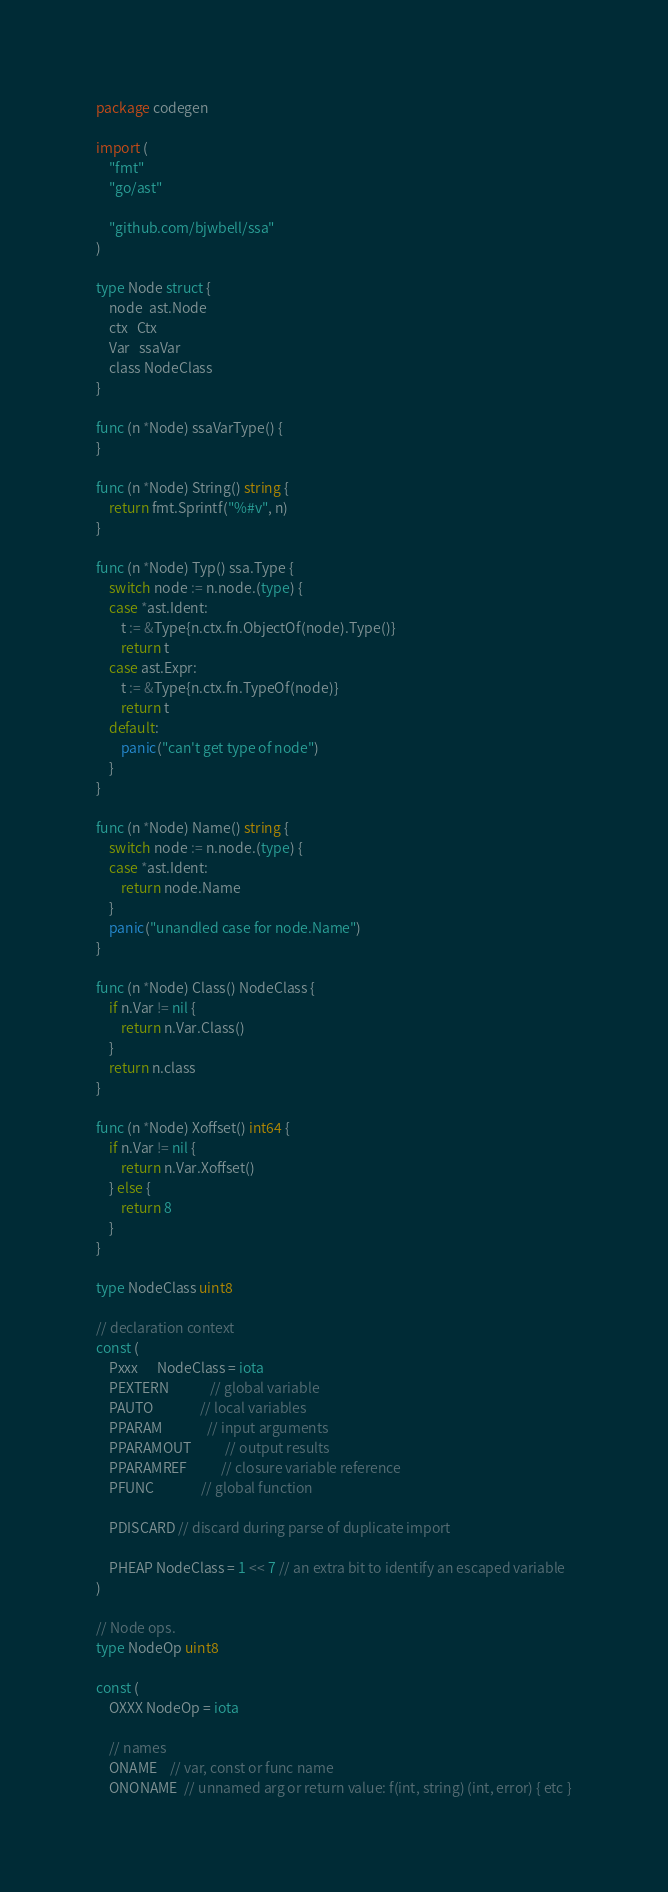Convert code to text. <code><loc_0><loc_0><loc_500><loc_500><_Go_>package codegen

import (
	"fmt"
	"go/ast"

	"github.com/bjwbell/ssa"
)

type Node struct {
	node  ast.Node
	ctx   Ctx
	Var   ssaVar
	class NodeClass
}

func (n *Node) ssaVarType() {
}

func (n *Node) String() string {
	return fmt.Sprintf("%#v", n)
}

func (n *Node) Typ() ssa.Type {
	switch node := n.node.(type) {
	case *ast.Ident:
		t := &Type{n.ctx.fn.ObjectOf(node).Type()}
		return t
	case ast.Expr:
		t := &Type{n.ctx.fn.TypeOf(node)}
		return t
	default:
		panic("can't get type of node")
	}
}

func (n *Node) Name() string {
	switch node := n.node.(type) {
	case *ast.Ident:
		return node.Name
	}
	panic("unandled case for node.Name")
}

func (n *Node) Class() NodeClass {
	if n.Var != nil {
		return n.Var.Class()
	}
	return n.class
}

func (n *Node) Xoffset() int64 {
	if n.Var != nil {
		return n.Var.Xoffset()
	} else {
		return 8
	}
}

type NodeClass uint8

// declaration context
const (
	Pxxx      NodeClass = iota
	PEXTERN             // global variable
	PAUTO               // local variables
	PPARAM              // input arguments
	PPARAMOUT           // output results
	PPARAMREF           // closure variable reference
	PFUNC               // global function

	PDISCARD // discard during parse of duplicate import

	PHEAP NodeClass = 1 << 7 // an extra bit to identify an escaped variable
)

// Node ops.
type NodeOp uint8

const (
	OXXX NodeOp = iota

	// names
	ONAME    // var, const or func name
	ONONAME  // unnamed arg or return value: f(int, string) (int, error) { etc }</code> 